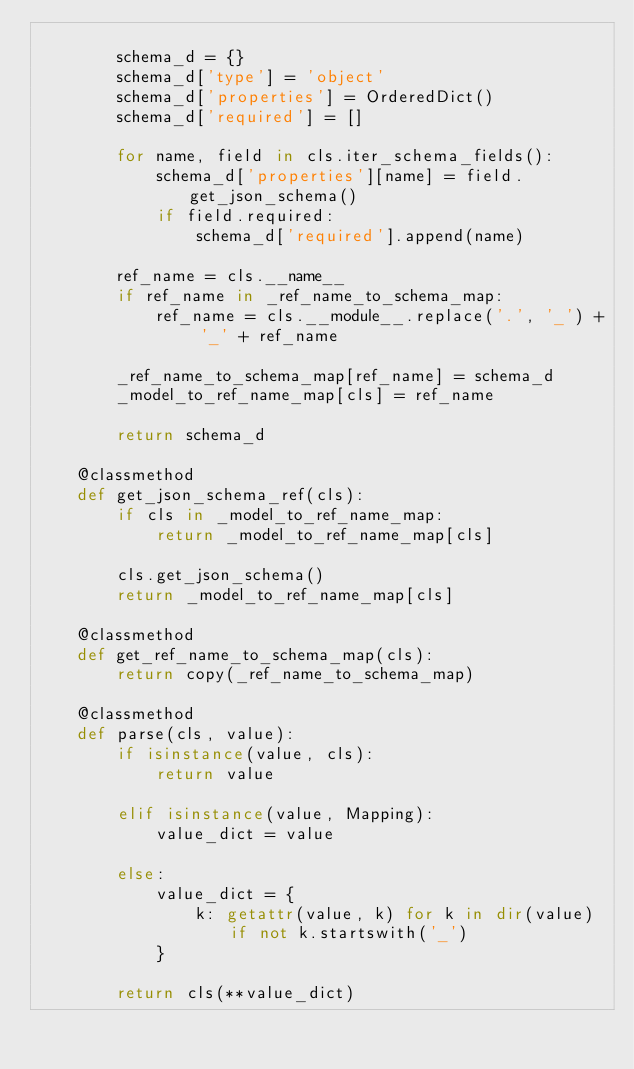<code> <loc_0><loc_0><loc_500><loc_500><_Python_>
        schema_d = {}
        schema_d['type'] = 'object'
        schema_d['properties'] = OrderedDict()
        schema_d['required'] = []

        for name, field in cls.iter_schema_fields():
            schema_d['properties'][name] = field.get_json_schema()
            if field.required:
                schema_d['required'].append(name)

        ref_name = cls.__name__
        if ref_name in _ref_name_to_schema_map:
            ref_name = cls.__module__.replace('.', '_') + '_' + ref_name

        _ref_name_to_schema_map[ref_name] = schema_d
        _model_to_ref_name_map[cls] = ref_name

        return schema_d

    @classmethod
    def get_json_schema_ref(cls):
        if cls in _model_to_ref_name_map:
            return _model_to_ref_name_map[cls]

        cls.get_json_schema()
        return _model_to_ref_name_map[cls]

    @classmethod
    def get_ref_name_to_schema_map(cls):
        return copy(_ref_name_to_schema_map)

    @classmethod
    def parse(cls, value):
        if isinstance(value, cls):
            return value

        elif isinstance(value, Mapping):
            value_dict = value

        else:
            value_dict = {
                k: getattr(value, k) for k in dir(value) if not k.startswith('_')
            }

        return cls(**value_dict)
</code> 